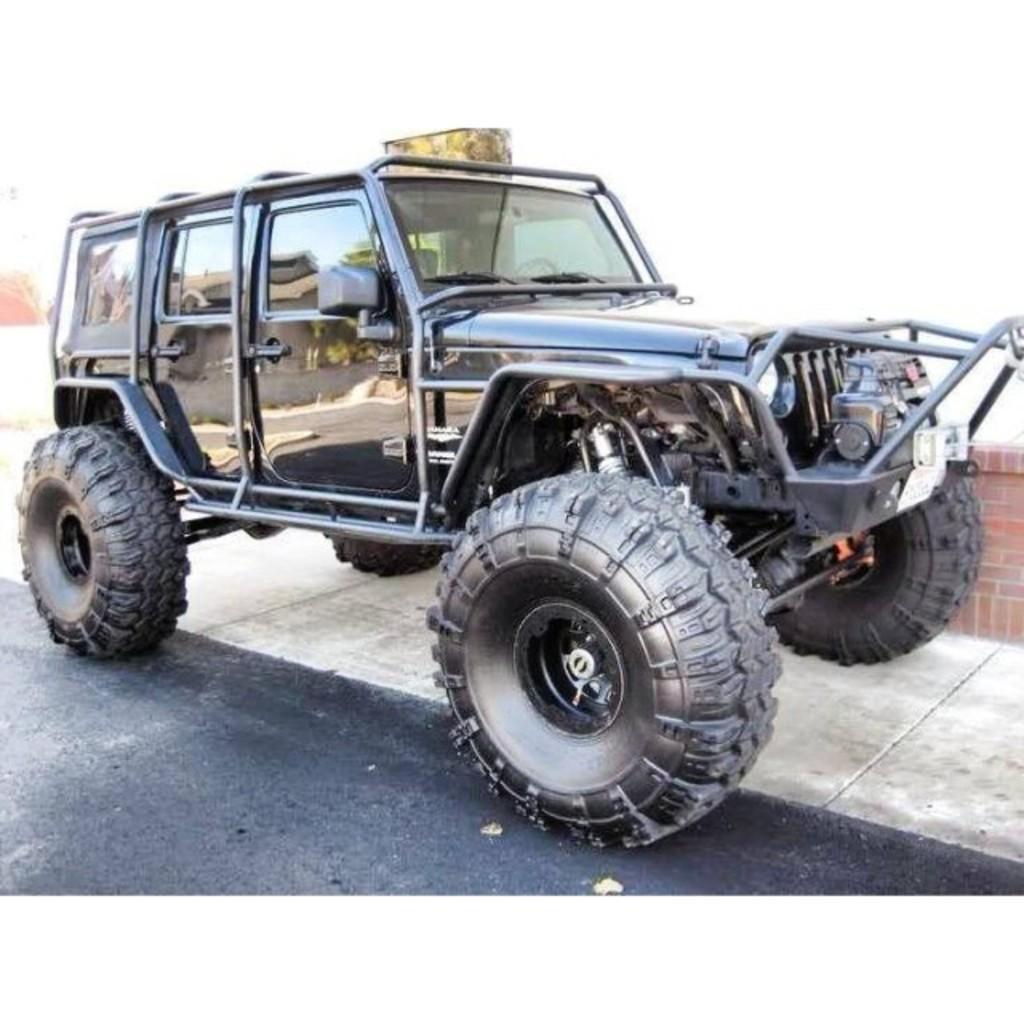Can you describe this image briefly? It is a jeep in black color, at the bottom it is the road in this image. 